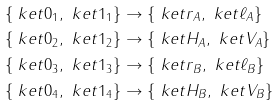Convert formula to latex. <formula><loc_0><loc_0><loc_500><loc_500>& \{ \ k e t { 0 } _ { 1 } , \ k e t { 1 } _ { 1 } \} \rightarrow \{ \ k e t { r } _ { A } , \ k e t { \ell } _ { A } \} \\ & \{ \ k e t { 0 } _ { 2 } , \ k e t { 1 } _ { 2 } \} \rightarrow \{ \ k e t { H } _ { A } , \ k e t { V } _ { A } \} \\ & \{ \ k e t { 0 } _ { 3 } , \ k e t { 1 } _ { 3 } \} \rightarrow \{ \ k e t { r } _ { B } , \ k e t { \ell } _ { B } \} \\ & \{ \ k e t { 0 } _ { 4 } , \ k e t { 1 } _ { 4 } \} \rightarrow \{ \ k e t { H } _ { B } , \ k e t { V } _ { B } \}</formula> 